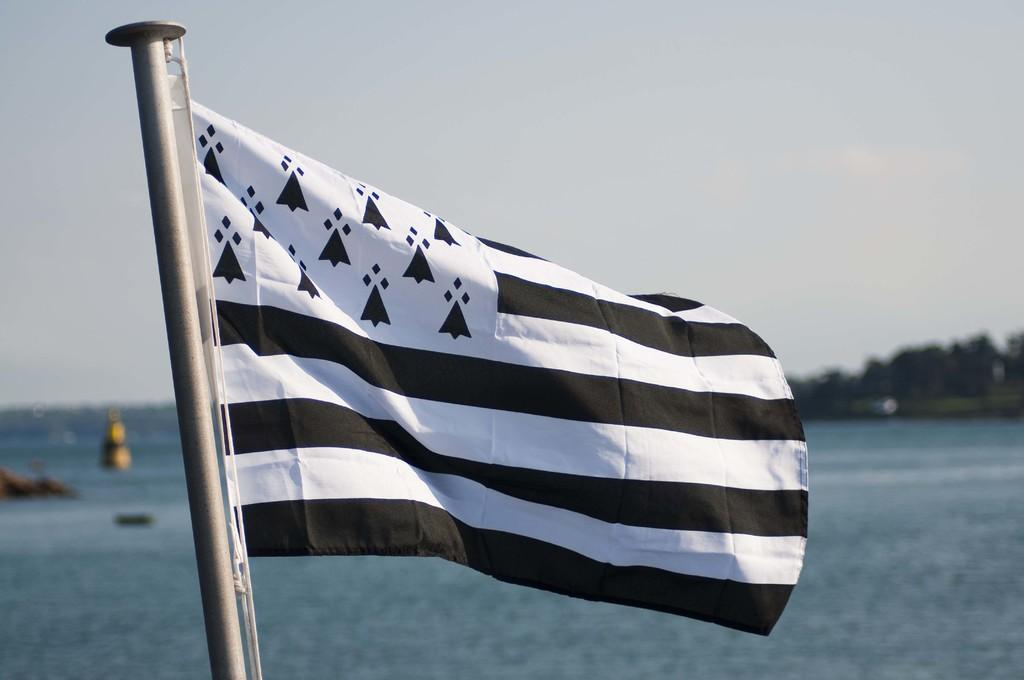What is the main object in the image? There is a flag in the image. What colors are used for the flag? The flag is in black and white color. What natural element can be seen in the image? There is water visible in the image. What is visible at the top of the image? The sky is visible at the top of the image. Can you tell me how many rods are used to hold the flag in the image? There is no rod present in the image; the flag is not shown being held up by any rods. What type of pen is being used to write on the flag in the image? There is no pen or writing on the flag in the image; it is simply a black and white flag. 